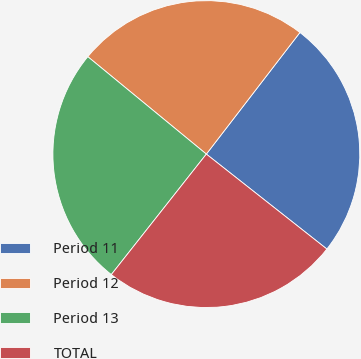<chart> <loc_0><loc_0><loc_500><loc_500><pie_chart><fcel>Period 11<fcel>Period 12<fcel>Period 13<fcel>TOTAL<nl><fcel>25.18%<fcel>24.49%<fcel>25.32%<fcel>25.01%<nl></chart> 